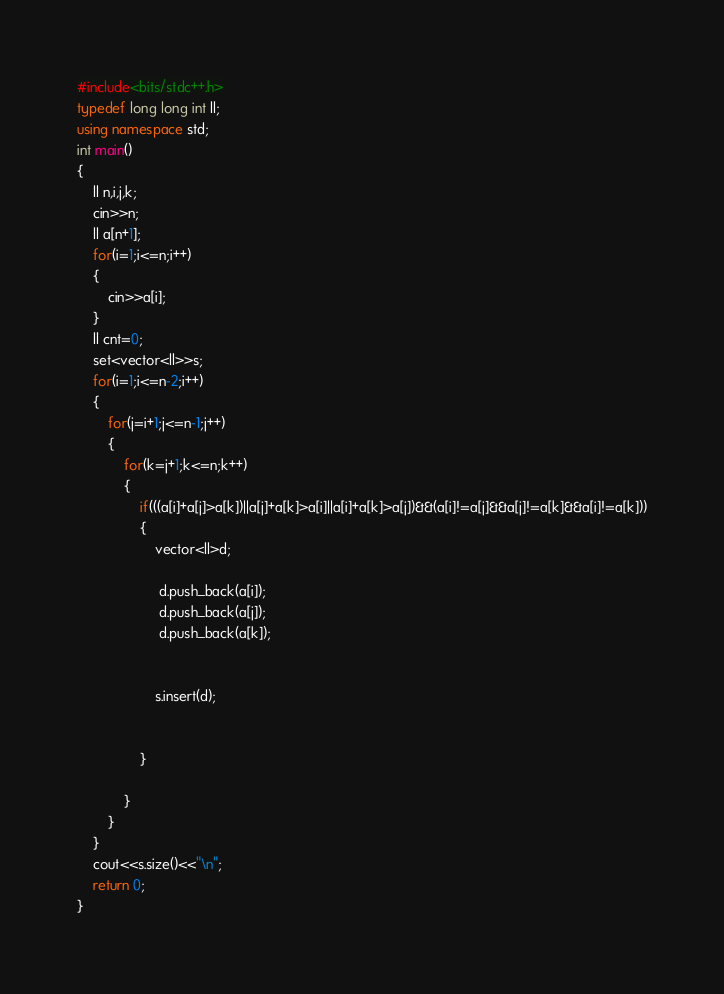<code> <loc_0><loc_0><loc_500><loc_500><_C++_>#include<bits/stdc++.h>
typedef long long int ll;
using namespace std;
int main()
{
    ll n,i,j,k;
    cin>>n;
    ll a[n+1];
    for(i=1;i<=n;i++)
    {
        cin>>a[i];
    }
    ll cnt=0;
    set<vector<ll>>s;
    for(i=1;i<=n-2;i++)
    {
        for(j=i+1;j<=n-1;j++)
        {
            for(k=j+1;k<=n;k++)
            {
                if(((a[i]+a[j]>a[k])||a[j]+a[k]>a[i]||a[i]+a[k]>a[j])&&(a[i]!=a[j]&&a[j]!=a[k]&&a[i]!=a[k]))
                {
                    vector<ll>d;
                   
                     d.push_back(a[i]);
                     d.push_back(a[j]);
                     d.push_back(a[k]);
                     
                     
                    s.insert(d);
                    
                    
                }
                
            }
        }
    }
    cout<<s.size()<<"\n";
    return 0;
}</code> 